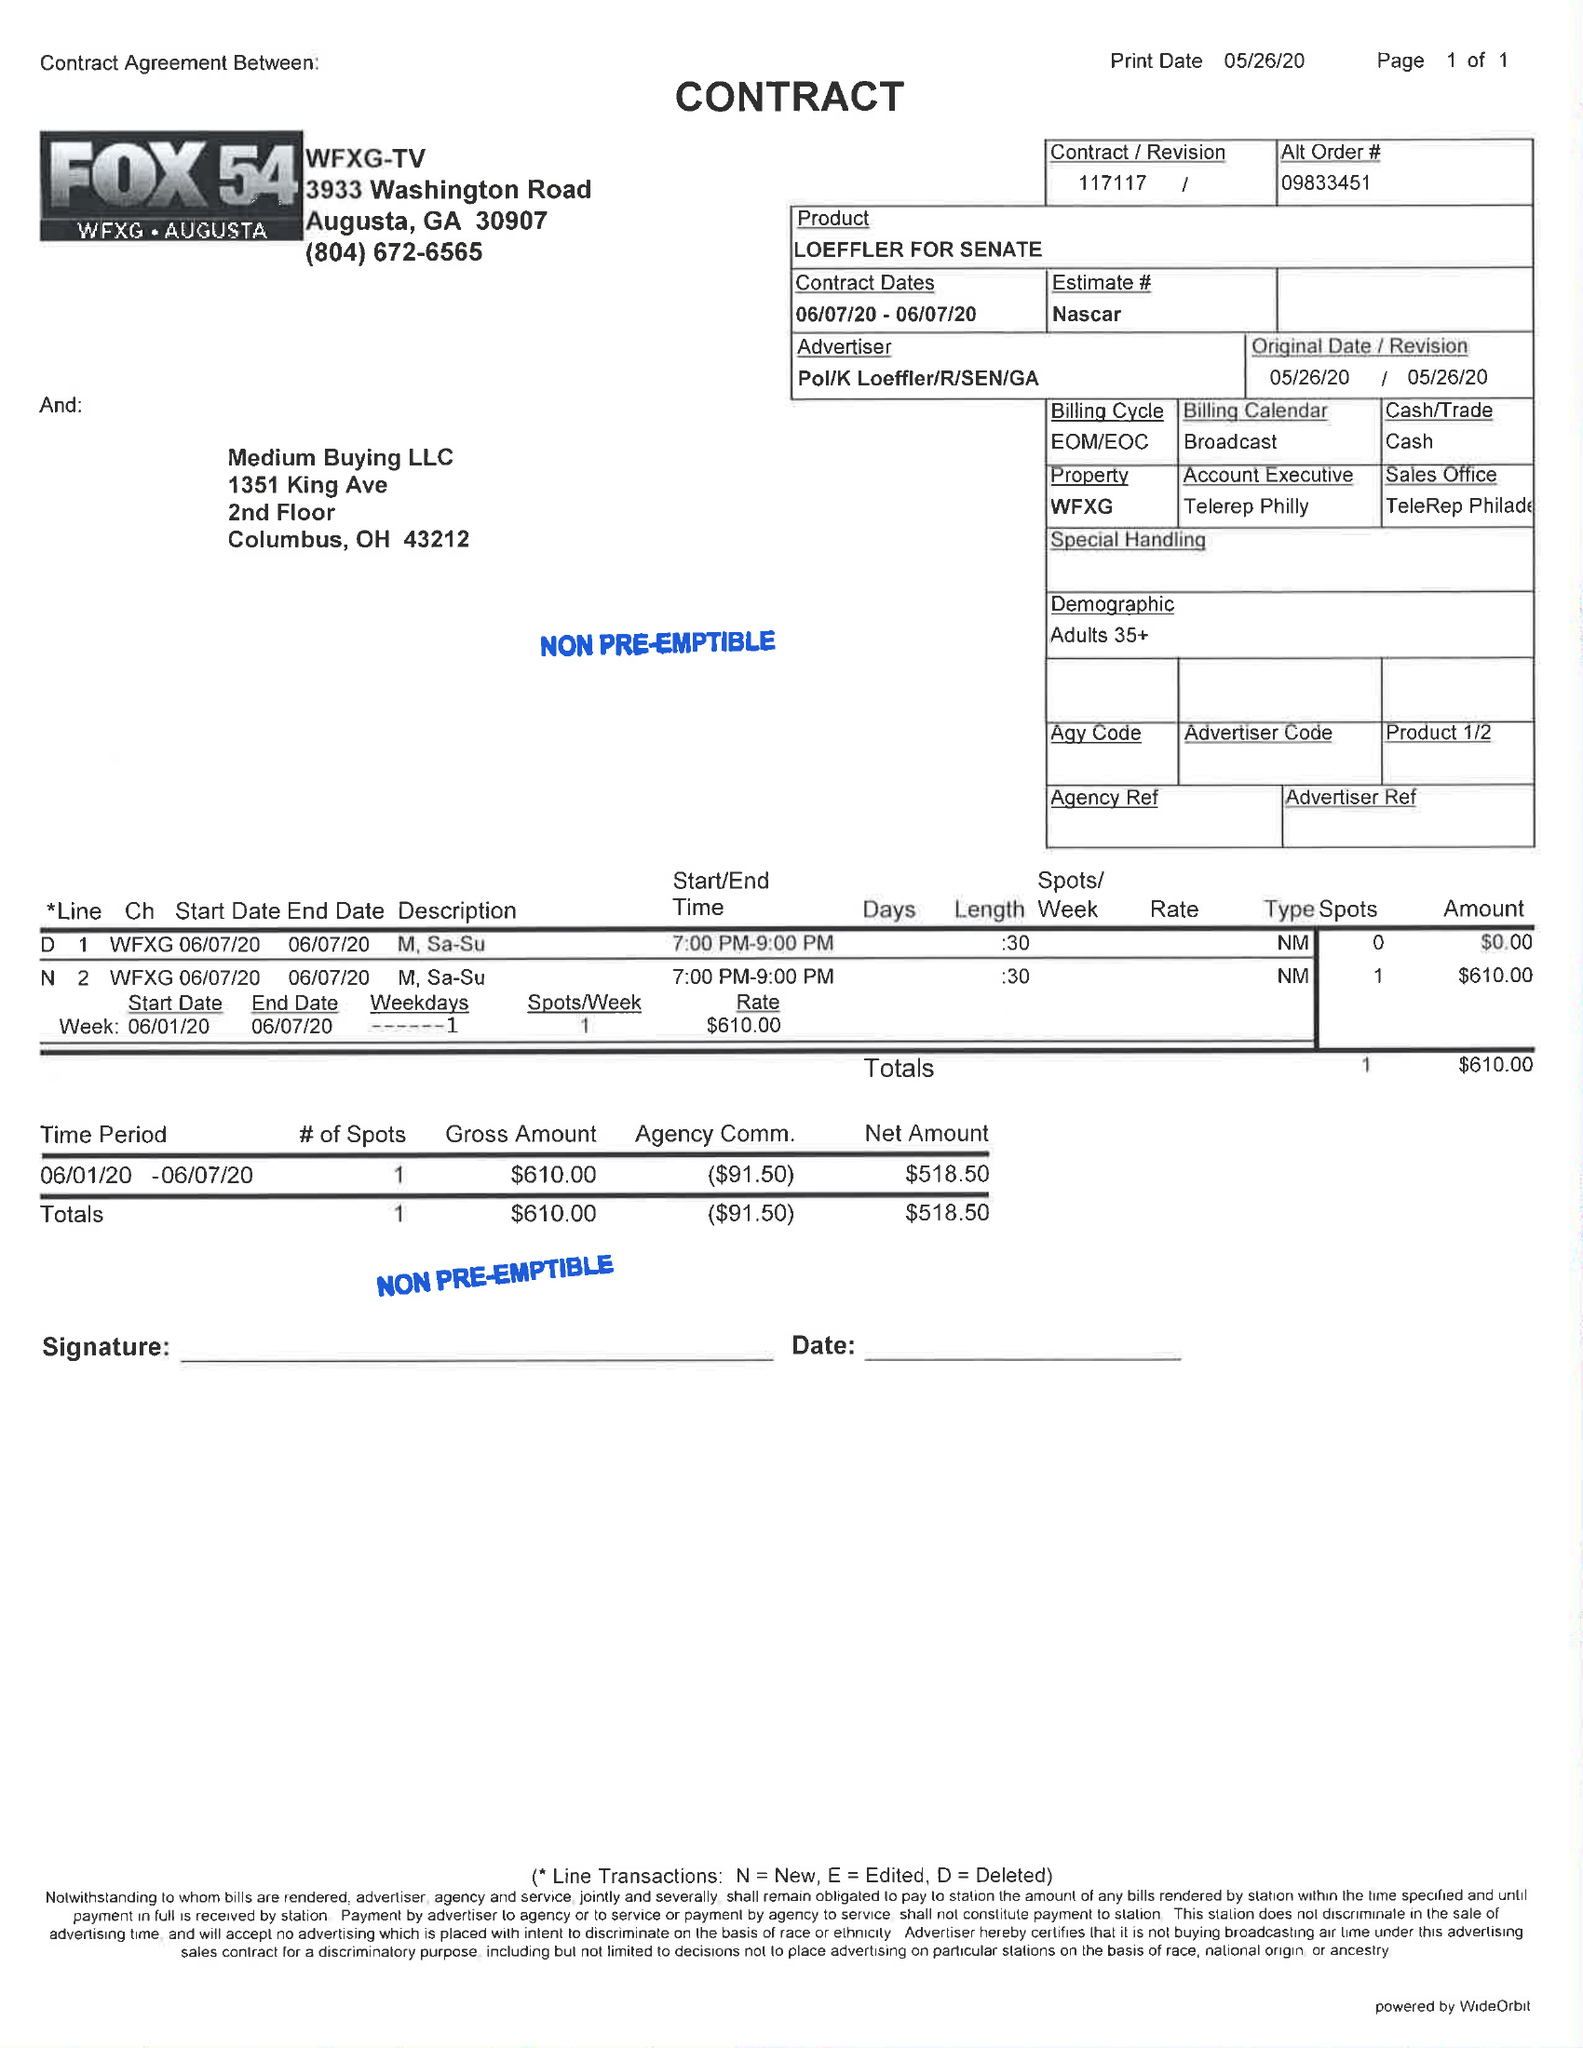What is the value for the flight_to?
Answer the question using a single word or phrase. 06/07/20 